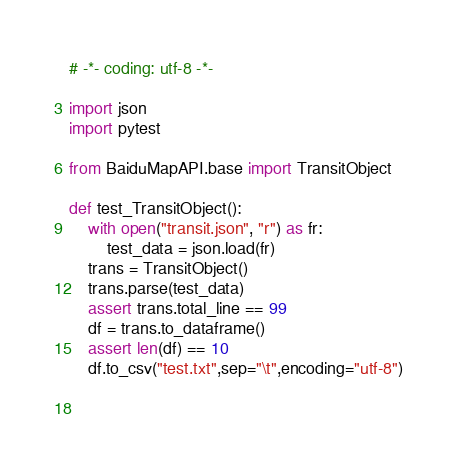<code> <loc_0><loc_0><loc_500><loc_500><_Python_># -*- coding: utf-8 -*- 

import json
import pytest

from BaiduMapAPI.base import TransitObject

def test_TransitObject():
    with open("transit.json", "r") as fr:
        test_data = json.load(fr)
    trans = TransitObject()
    trans.parse(test_data)
    assert trans.total_line == 99
    df = trans.to_dataframe()
    assert len(df) == 10
    df.to_csv("test.txt",sep="\t",encoding="utf-8")

    </code> 